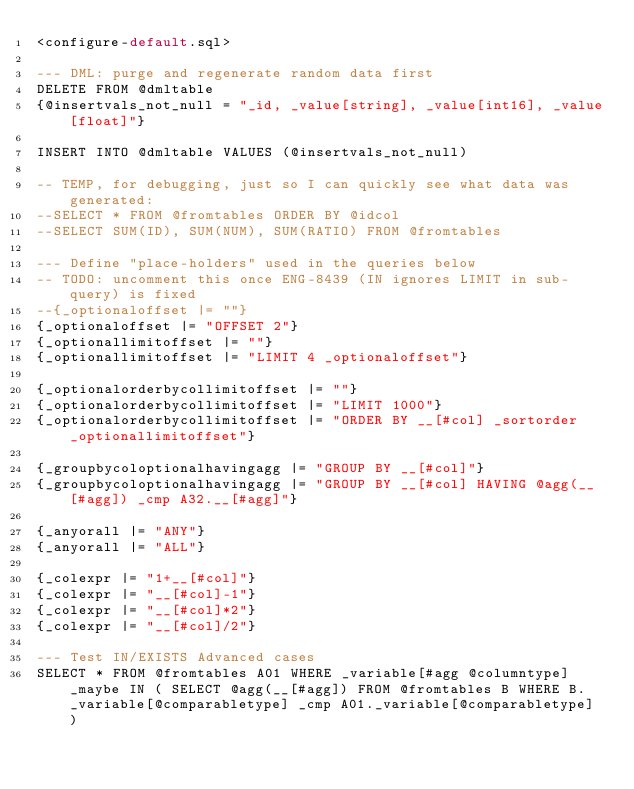Convert code to text. <code><loc_0><loc_0><loc_500><loc_500><_SQL_><configure-default.sql>

--- DML: purge and regenerate random data first
DELETE FROM @dmltable
{@insertvals_not_null = "_id, _value[string], _value[int16], _value[float]"}

INSERT INTO @dmltable VALUES (@insertvals_not_null)

-- TEMP, for debugging, just so I can quickly see what data was generated:
--SELECT * FROM @fromtables ORDER BY @idcol
--SELECT SUM(ID), SUM(NUM), SUM(RATIO) FROM @fromtables

--- Define "place-holders" used in the queries below
-- TODO: uncomment this once ENG-8439 (IN ignores LIMIT in sub-query) is fixed
--{_optionaloffset |= ""}
{_optionaloffset |= "OFFSET 2"}
{_optionallimitoffset |= ""}
{_optionallimitoffset |= "LIMIT 4 _optionaloffset"}

{_optionalorderbycollimitoffset |= ""}
{_optionalorderbycollimitoffset |= "LIMIT 1000"}
{_optionalorderbycollimitoffset |= "ORDER BY __[#col] _sortorder _optionallimitoffset"}

{_groupbycoloptionalhavingagg |= "GROUP BY __[#col]"}
{_groupbycoloptionalhavingagg |= "GROUP BY __[#col] HAVING @agg(__[#agg]) _cmp A32.__[#agg]"}

{_anyorall |= "ANY"}
{_anyorall |= "ALL"}

{_colexpr |= "1+__[#col]"}
{_colexpr |= "__[#col]-1"}
{_colexpr |= "__[#col]*2"}
{_colexpr |= "__[#col]/2"}

--- Test IN/EXISTS Advanced cases
SELECT * FROM @fromtables A01 WHERE _variable[#agg @columntype] _maybe IN ( SELECT @agg(__[#agg]) FROM @fromtables B WHERE B._variable[@comparabletype] _cmp A01._variable[@comparabletype] )</code> 